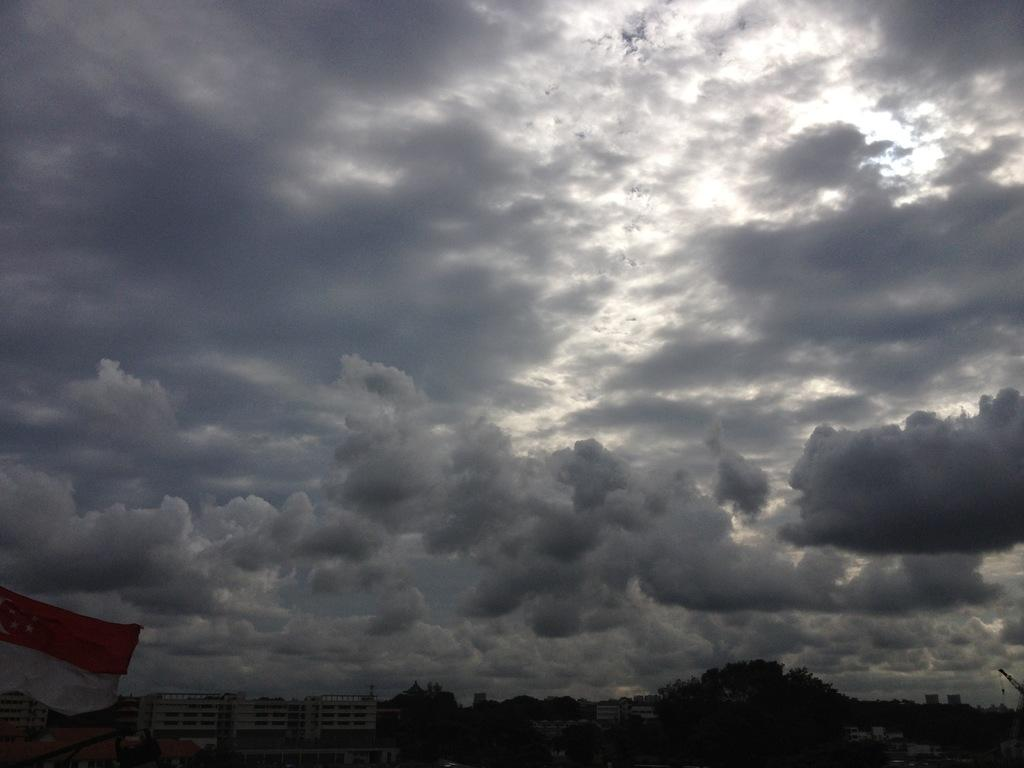What types of structures are visible at the bottom of the image? There are trees and buildings at the bottom of the image. What object can be seen on the left side of the image? There is a cloth on the left side of the image. What is visible at the top of the image? The sky is visible at the top of the image. What color is the crayon being used by the team in the image? There is no crayon or team present in the image. How many basketballs can be seen in the image? There are no basketballs present in the image. 